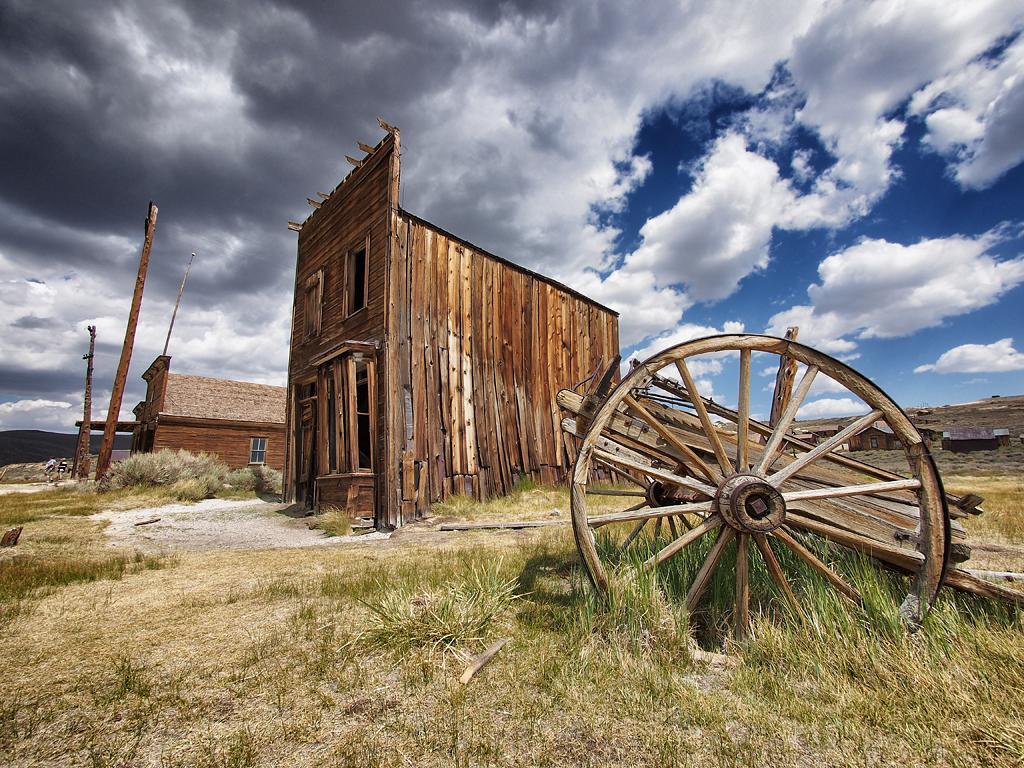In one or two sentences, can you explain what this image depicts? In this image I can see the grass. I can see the wooden coach. In the background, I can see the wooden houses and clouds in the sky. 